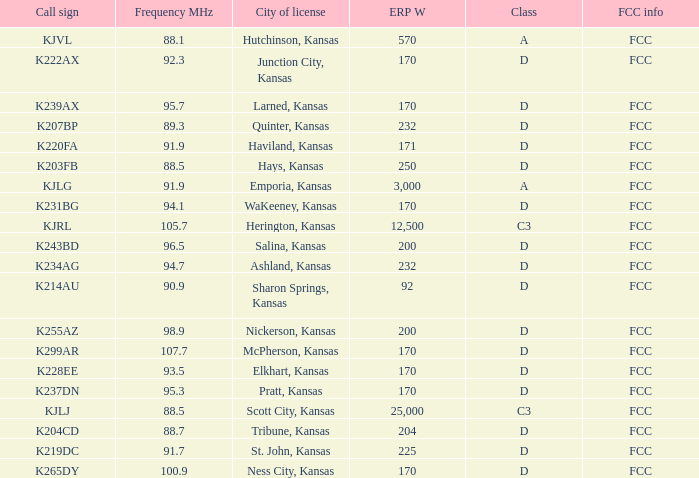Frequency MHz of 88.7 had what average erp w? 204.0. 